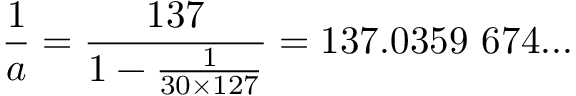Convert formula to latex. <formula><loc_0><loc_0><loc_500><loc_500>{ \frac { 1 } { a } } = { \frac { 1 3 7 } { 1 - { \frac { 1 } { 3 0 \times 1 2 7 } } } } = 1 3 7 . 0 3 5 9 \ 6 7 4 \dots</formula> 